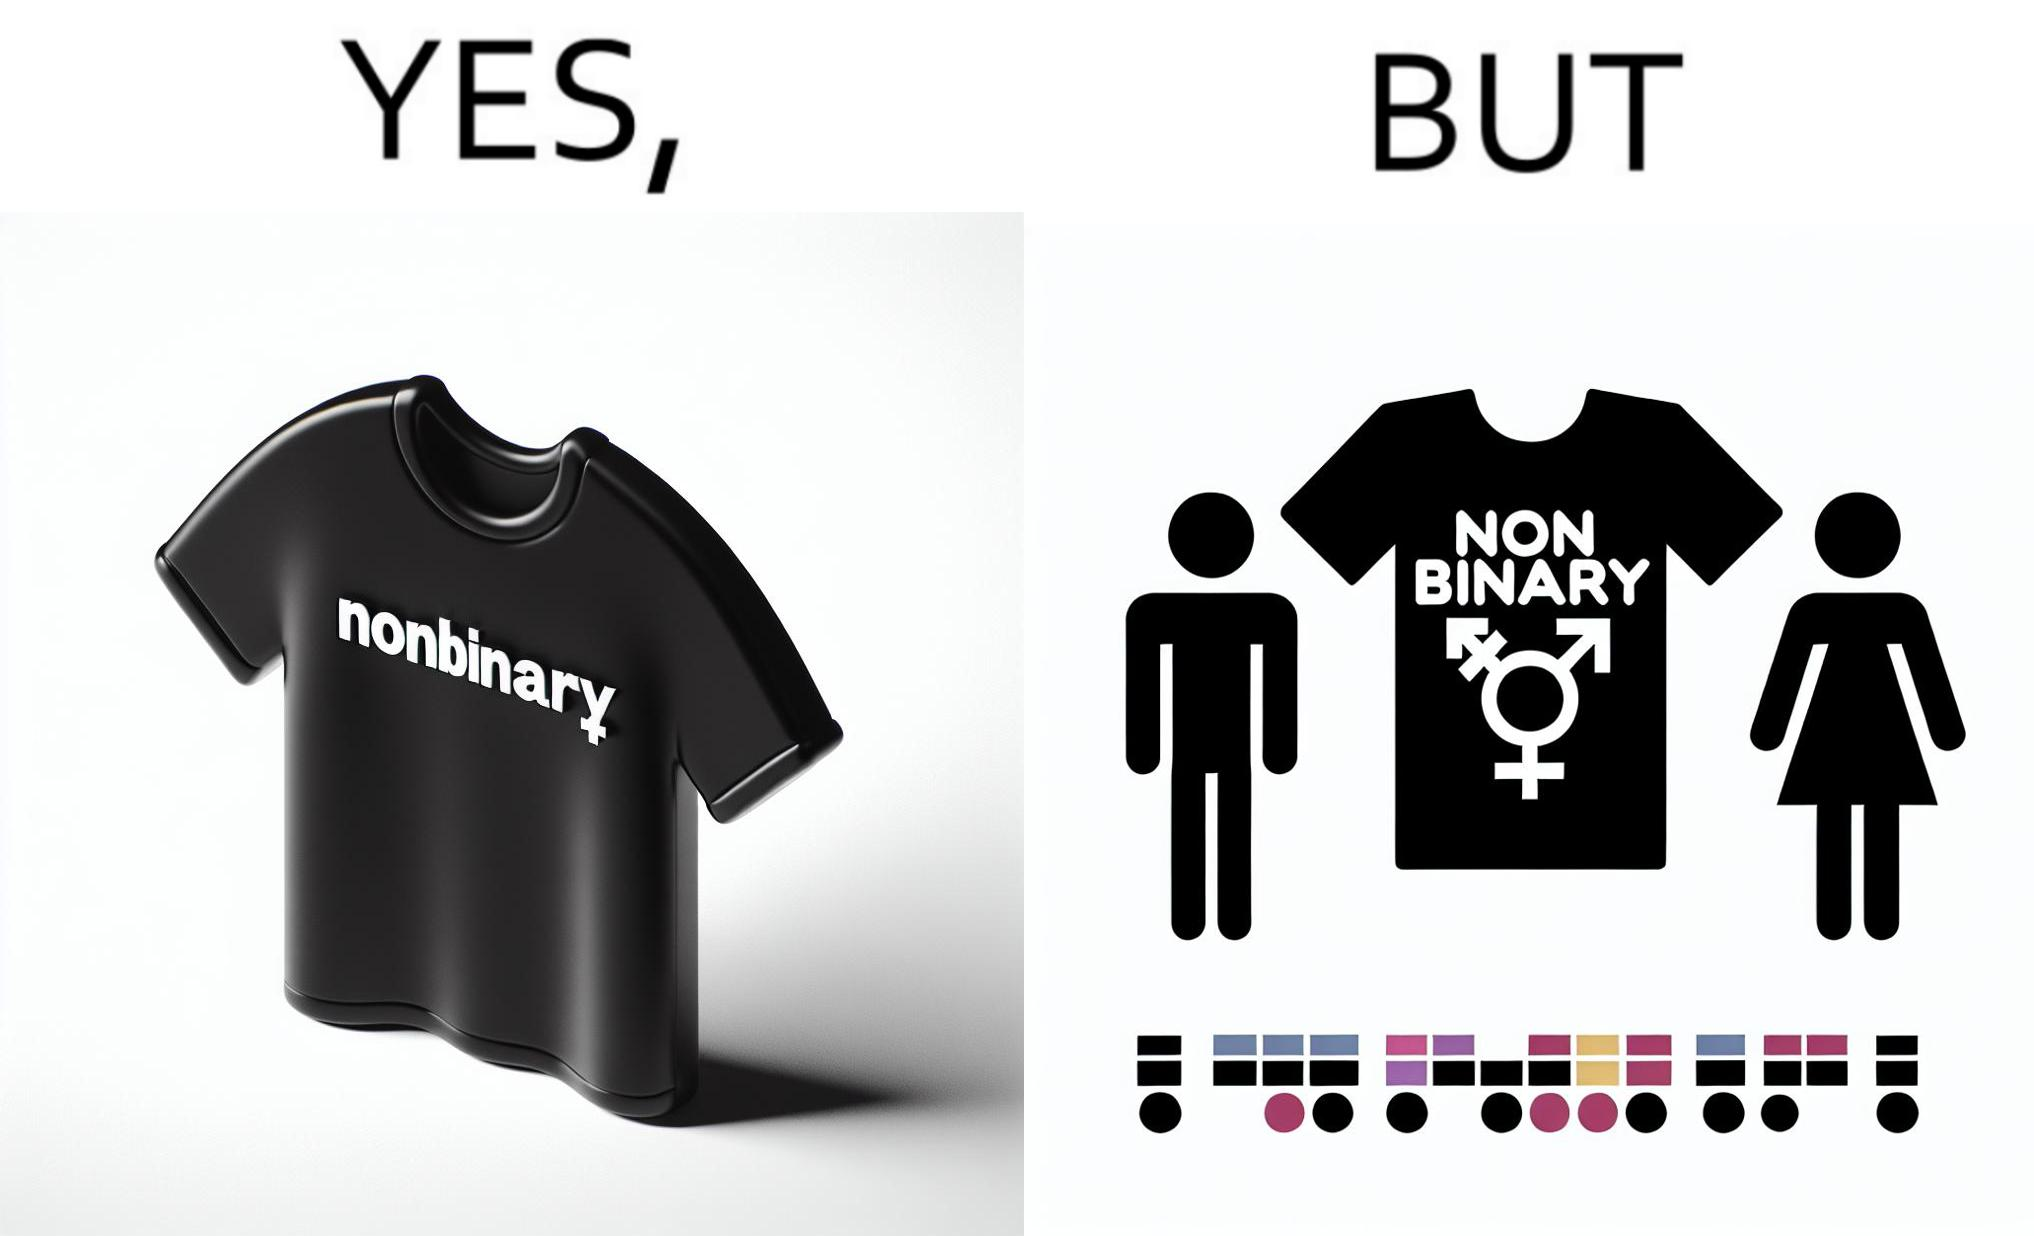What does this image depict? The image is ironic, as the t-shirt that says "NONBINARY" has only 2 options for gender on an online retail forum. 